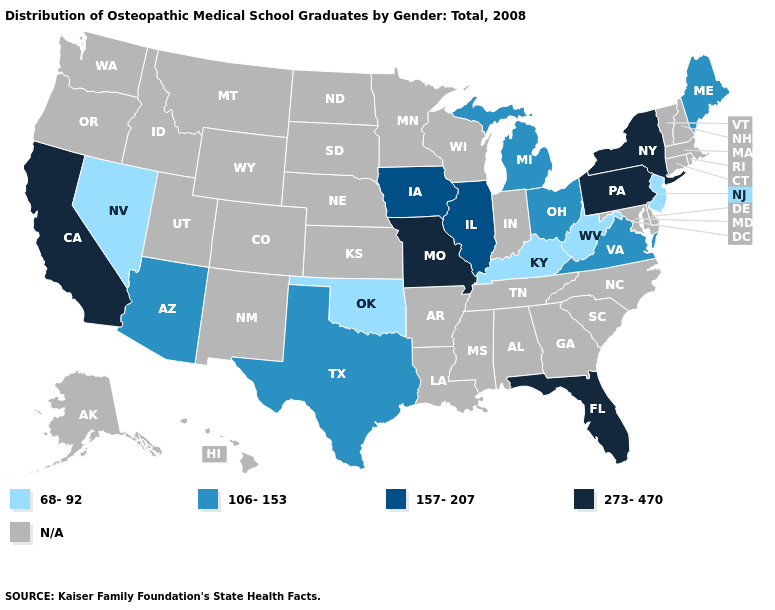Name the states that have a value in the range 157-207?
Keep it brief. Illinois, Iowa. Does West Virginia have the lowest value in the USA?
Short answer required. Yes. Name the states that have a value in the range 157-207?
Keep it brief. Illinois, Iowa. What is the value of Tennessee?
Short answer required. N/A. What is the lowest value in states that border Georgia?
Quick response, please. 273-470. Which states have the lowest value in the USA?
Write a very short answer. Kentucky, Nevada, New Jersey, Oklahoma, West Virginia. Name the states that have a value in the range 68-92?
Short answer required. Kentucky, Nevada, New Jersey, Oklahoma, West Virginia. What is the value of Maryland?
Quick response, please. N/A. Does Illinois have the lowest value in the MidWest?
Be succinct. No. Does Virginia have the lowest value in the South?
Concise answer only. No. What is the highest value in the USA?
Give a very brief answer. 273-470. Name the states that have a value in the range N/A?
Write a very short answer. Alabama, Alaska, Arkansas, Colorado, Connecticut, Delaware, Georgia, Hawaii, Idaho, Indiana, Kansas, Louisiana, Maryland, Massachusetts, Minnesota, Mississippi, Montana, Nebraska, New Hampshire, New Mexico, North Carolina, North Dakota, Oregon, Rhode Island, South Carolina, South Dakota, Tennessee, Utah, Vermont, Washington, Wisconsin, Wyoming. 